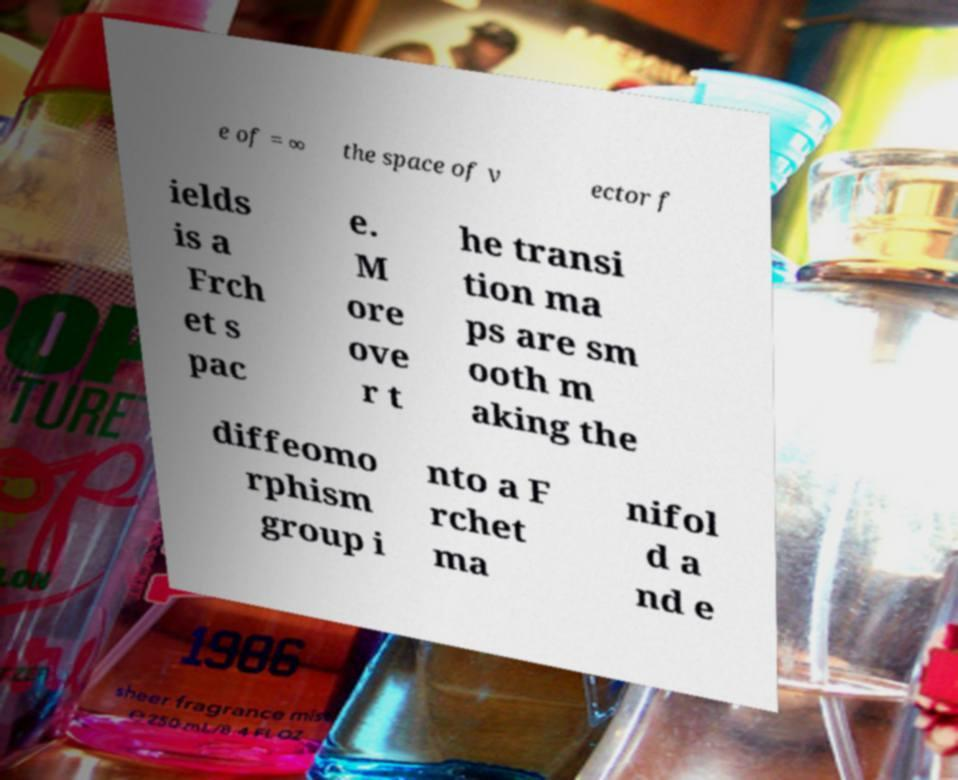Can you accurately transcribe the text from the provided image for me? e of = ∞ the space of v ector f ields is a Frch et s pac e. M ore ove r t he transi tion ma ps are sm ooth m aking the diffeomo rphism group i nto a F rchet ma nifol d a nd e 